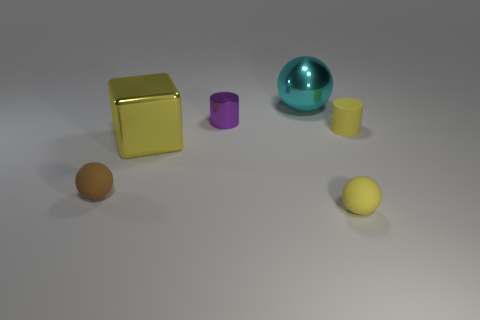Add 3 large cyan things. How many objects exist? 9 Subtract all tiny rubber balls. How many balls are left? 1 Subtract all cylinders. How many objects are left? 4 Subtract all tiny green shiny things. Subtract all large metallic cubes. How many objects are left? 5 Add 4 large shiny cubes. How many large shiny cubes are left? 5 Add 2 large blue blocks. How many large blue blocks exist? 2 Subtract 0 cyan cylinders. How many objects are left? 6 